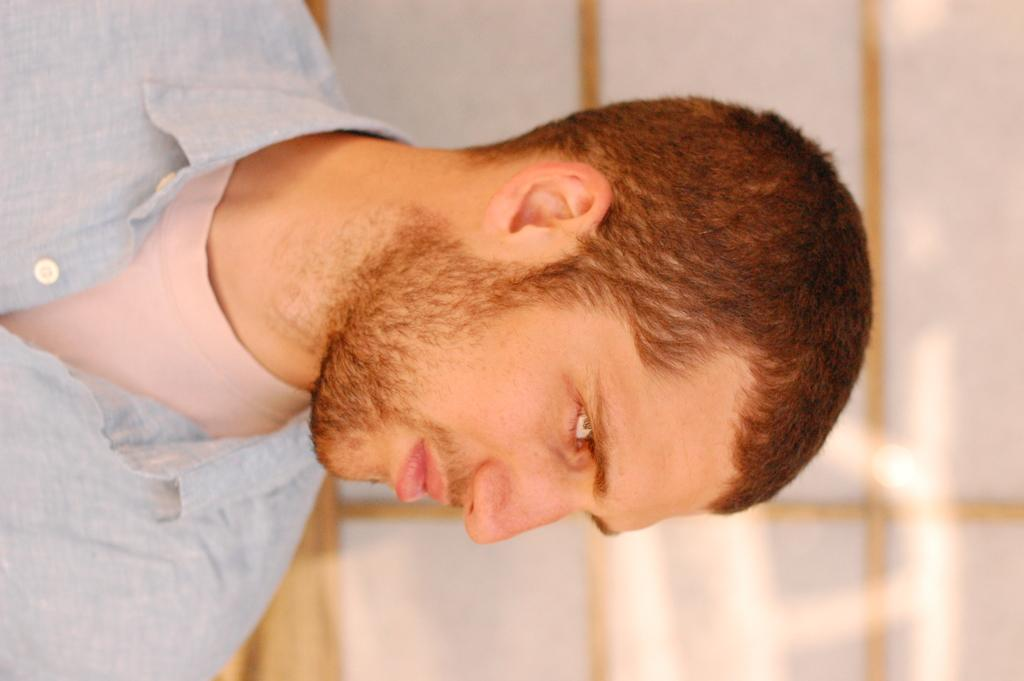What is the main subject of the image? There is a person in the image. What type of oil is being used by the person in the image? There is no oil present in the image, as the only fact provided is that there is a person in the image. 